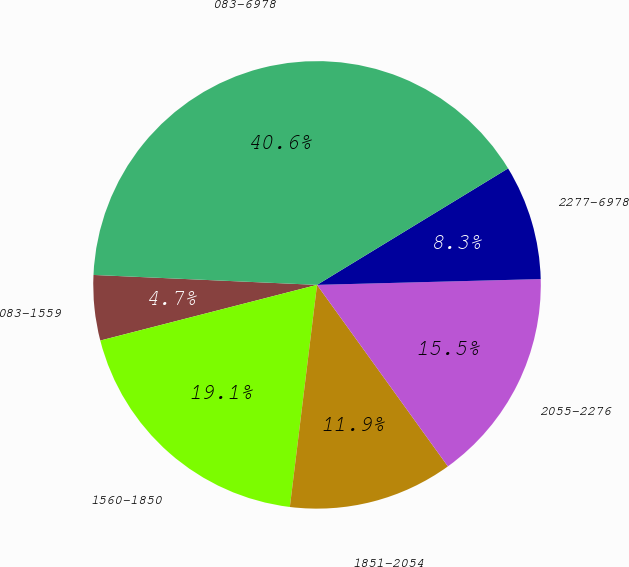<chart> <loc_0><loc_0><loc_500><loc_500><pie_chart><fcel>083-1559<fcel>1560-1850<fcel>1851-2054<fcel>2055-2276<fcel>2277-6978<fcel>083-6978<nl><fcel>4.71%<fcel>19.06%<fcel>11.88%<fcel>15.47%<fcel>8.3%<fcel>40.58%<nl></chart> 